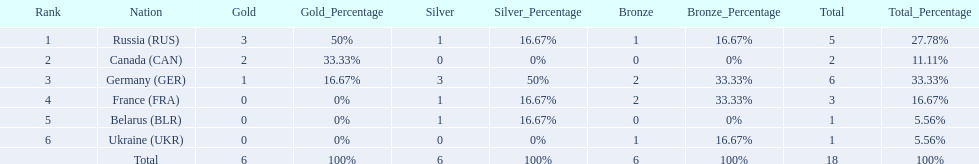What are all the countries in the 1994 winter olympics biathlon? Russia (RUS), Canada (CAN), Germany (GER), France (FRA), Belarus (BLR), Ukraine (UKR). Which of these received at least one gold medal? Russia (RUS), Canada (CAN), Germany (GER). Which of these received no silver or bronze medals? Canada (CAN). 